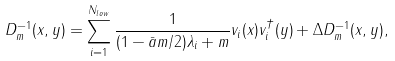<formula> <loc_0><loc_0><loc_500><loc_500>D ^ { - 1 } _ { m } ( x , y ) = \sum _ { i = 1 } ^ { N _ { l o w } } \frac { 1 } { ( 1 - \bar { a } m / 2 ) \lambda _ { i } + m } v _ { i } ( x ) v _ { i } ^ { \dagger } ( y ) + \Delta D _ { m } ^ { - 1 } ( x , y ) ,</formula> 